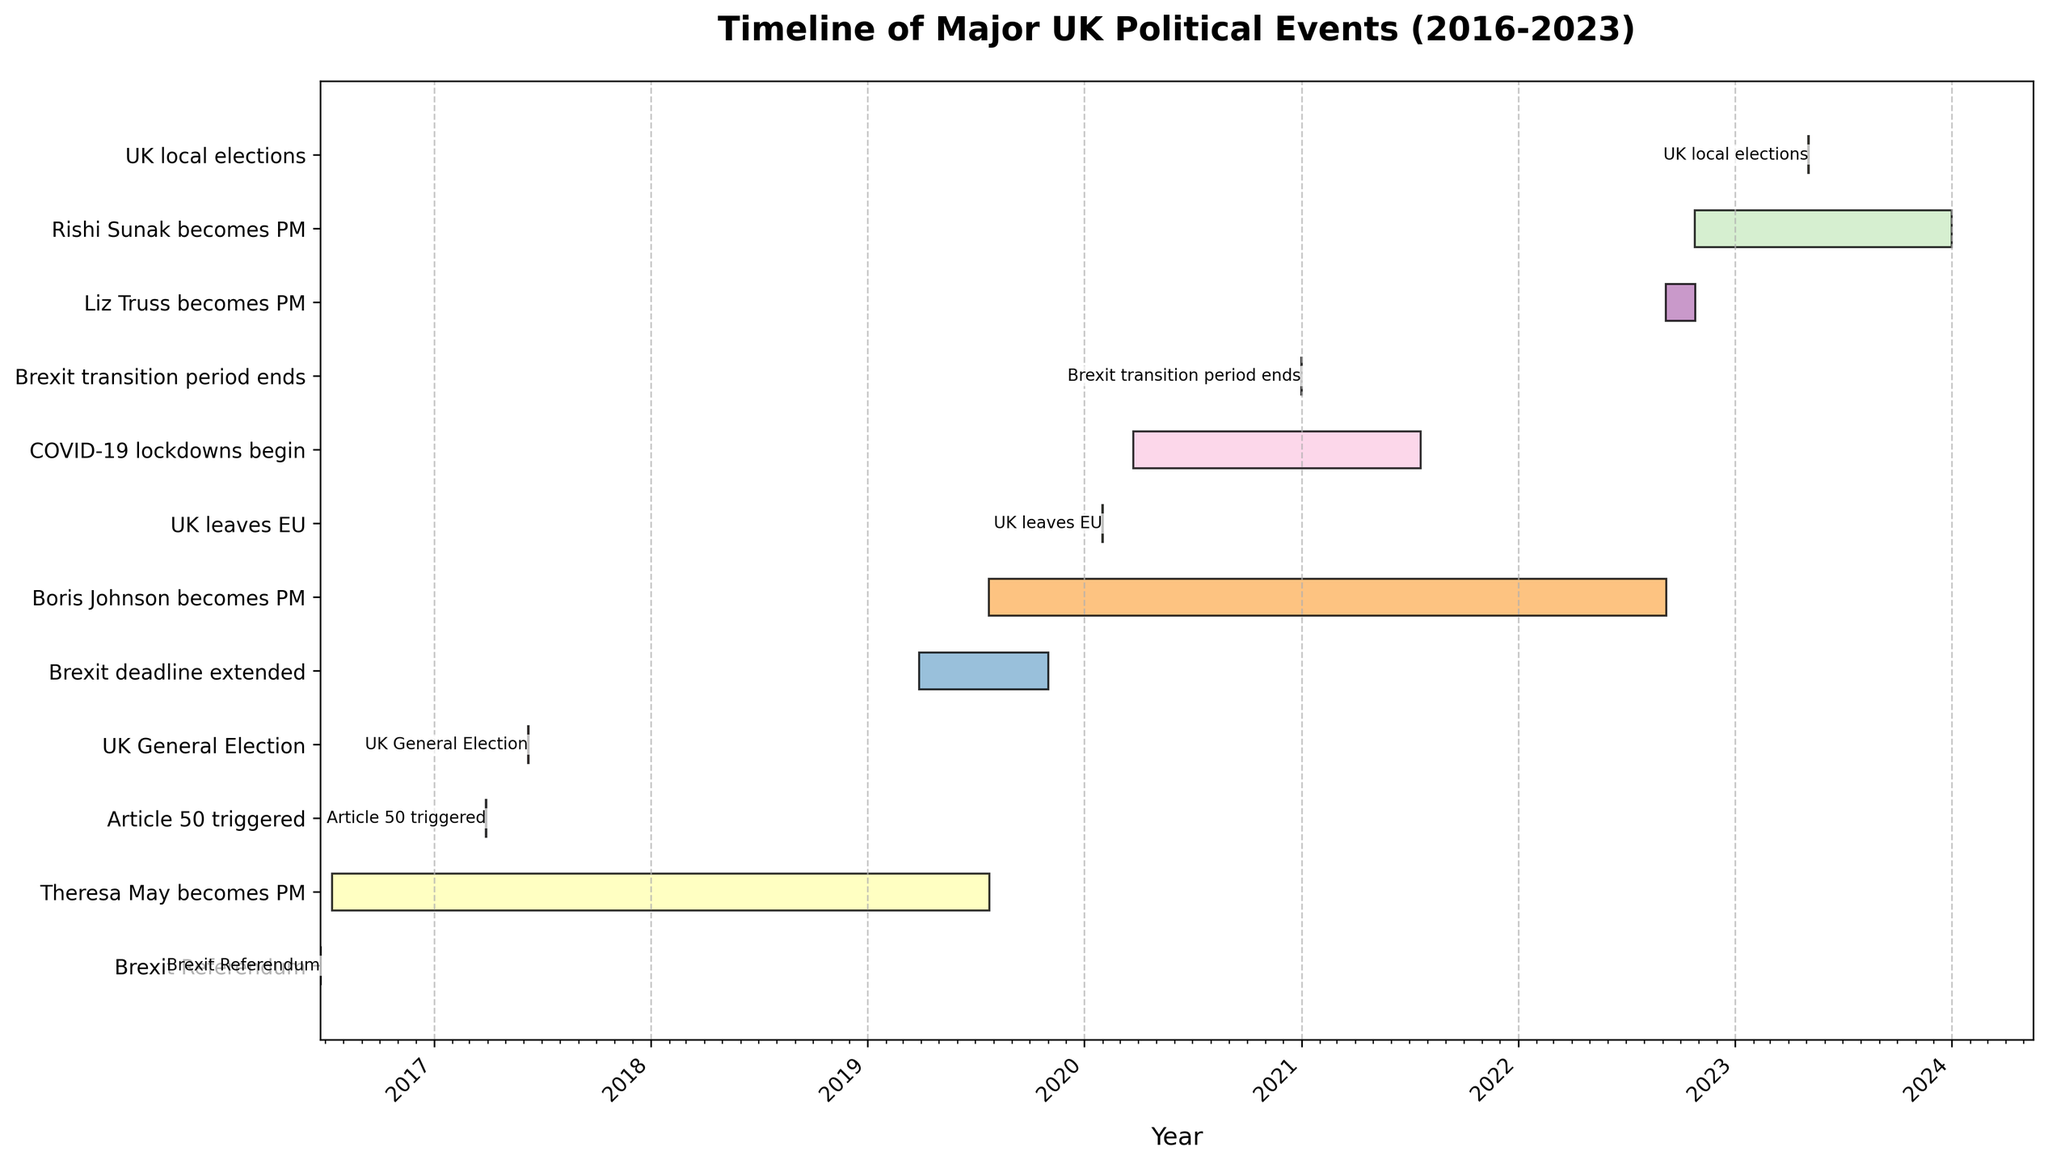When did the Brexit referendum take place? The chart shows a vertical bar for the Brexit referendum aligned to the year 2016 on the horizontal axis, with a date label indicating the exact day.
Answer: 23rd June 2016 How long was Theresa May in office as Prime Minister? The Gantt bar for Theresa May's tenure as PM starts in July 2016 and ends in July 2019. Therefore, we calculate the number of years and months between these dates.
Answer: 3 years and 11 days Which Prime Minister had the shortest tenure between Theresa May, Boris Johnson, and Liz Truss? By comparing the lengths of the bars, the duration of Liz Truss's tenure is the shortest as it spans only from September to October 2022, less than three months.
Answer: Liz Truss What major political event in the UK marked the end of 2020? The chart shows bars and labels for significant events, with the "Brexit transition period ends" bar situated near the end of 2020.
Answer: Brexit transition period ends Which event initiated the UK's COVID-19 lockdown? The chart includes a bar corresponding to "COVID-19 lockdowns begin" and it starts in March 2020 as per the timeline.
Answer: COVID-19 lockdowns begin How many major political events happened in 2019? The bars in 2019 include "Brexit deadline extended" and "Boris Johnson becomes PM." We count these events.
Answer: 2 Which Prime Minister was in office during the UK's official exit from the EU? The UK leaves the EU in January 2020, as marked on the chart. The bar for Boris Johnson being Prime Minister overlaps with this date.
Answer: Boris Johnson What is the duration between the triggering of Article 50 and the UK's actual departure from the EU? Article 50 was triggered in March 2017 and the UK left the EU in January 2020. The time difference is approximately 2 years and 10 months.
Answer: About 2 years and 10 months What do the different colors represent on the Gantt chart? The colors differentiate between the various political events and timelines represented on the chart. Each event has a distinct color to make it visually distinguishable from the others.
Answer: Different events 